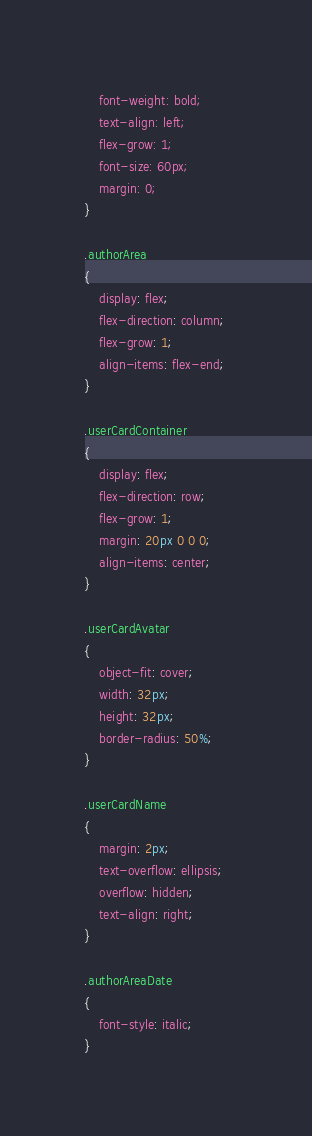<code> <loc_0><loc_0><loc_500><loc_500><_CSS_>    font-weight: bold;
    text-align: left;
    flex-grow: 1;
    font-size: 60px;
    margin: 0;
}

.authorArea
{
    display: flex;
    flex-direction: column;
    flex-grow: 1;
    align-items: flex-end;
}

.userCardContainer
{
    display: flex;
    flex-direction: row;
    flex-grow: 1;
    margin: 20px 0 0 0;
    align-items: center;
}

.userCardAvatar
{
    object-fit: cover;
    width: 32px;
    height: 32px;
    border-radius: 50%;    
}

.userCardName
{
    margin: 2px;
    text-overflow: ellipsis;
    overflow: hidden;
    text-align: right;
}

.authorAreaDate
{
    font-style: italic;    
}
</code> 